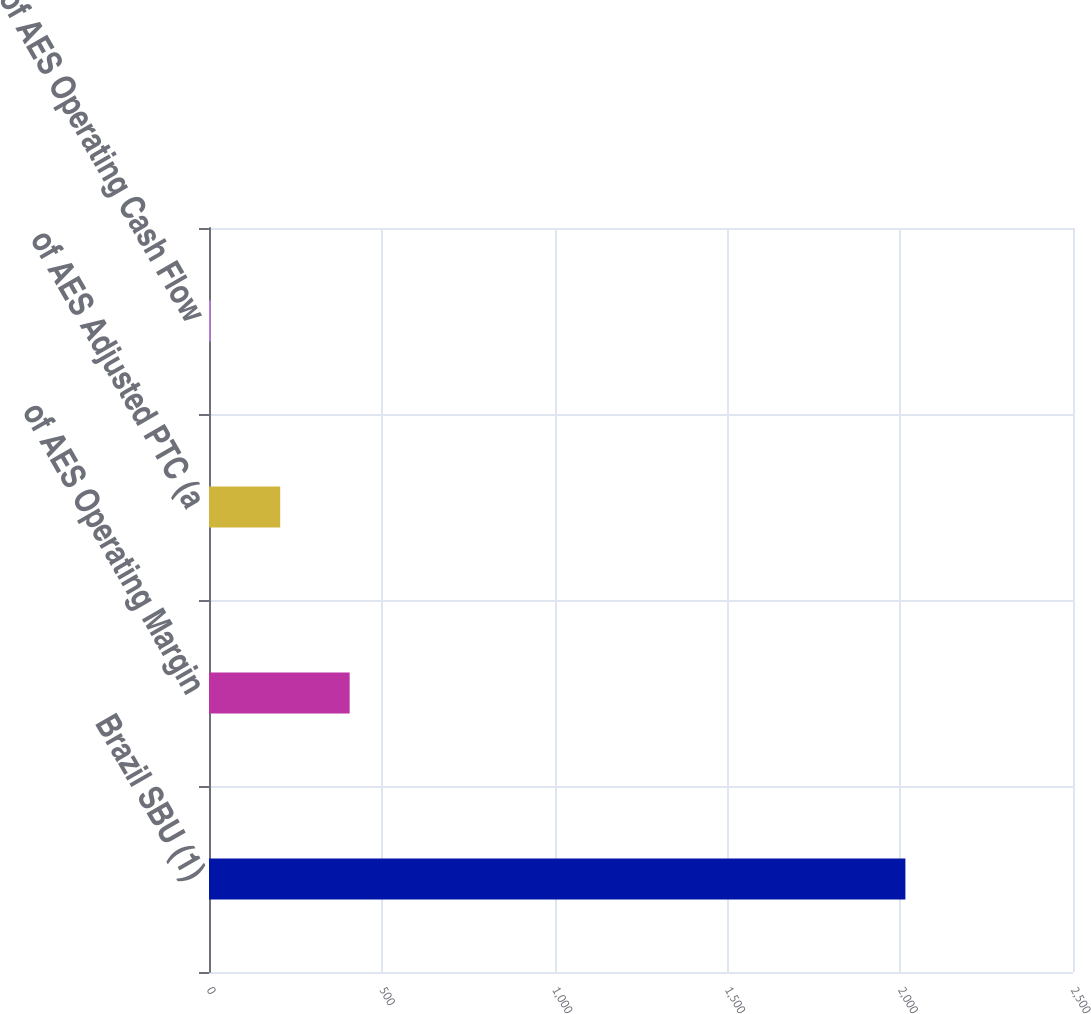Convert chart. <chart><loc_0><loc_0><loc_500><loc_500><bar_chart><fcel>Brazil SBU (1)<fcel>of AES Operating Margin<fcel>of AES Adjusted PTC (a<fcel>of AES Operating Cash Flow<nl><fcel>2015<fcel>407<fcel>206<fcel>5<nl></chart> 